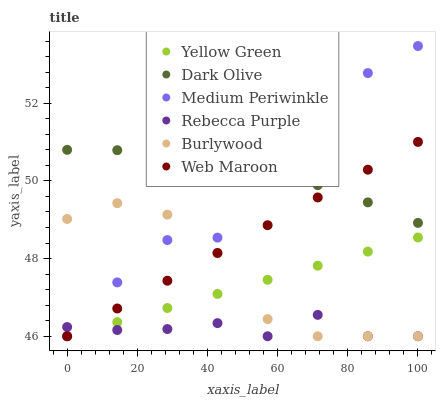Does Rebecca Purple have the minimum area under the curve?
Answer yes or no. Yes. Does Dark Olive have the maximum area under the curve?
Answer yes or no. Yes. Does Burlywood have the minimum area under the curve?
Answer yes or no. No. Does Burlywood have the maximum area under the curve?
Answer yes or no. No. Is Yellow Green the smoothest?
Answer yes or no. Yes. Is Medium Periwinkle the roughest?
Answer yes or no. Yes. Is Burlywood the smoothest?
Answer yes or no. No. Is Burlywood the roughest?
Answer yes or no. No. Does Yellow Green have the lowest value?
Answer yes or no. Yes. Does Dark Olive have the lowest value?
Answer yes or no. No. Does Medium Periwinkle have the highest value?
Answer yes or no. Yes. Does Burlywood have the highest value?
Answer yes or no. No. Is Yellow Green less than Dark Olive?
Answer yes or no. Yes. Is Dark Olive greater than Burlywood?
Answer yes or no. Yes. Does Rebecca Purple intersect Burlywood?
Answer yes or no. Yes. Is Rebecca Purple less than Burlywood?
Answer yes or no. No. Is Rebecca Purple greater than Burlywood?
Answer yes or no. No. Does Yellow Green intersect Dark Olive?
Answer yes or no. No. 